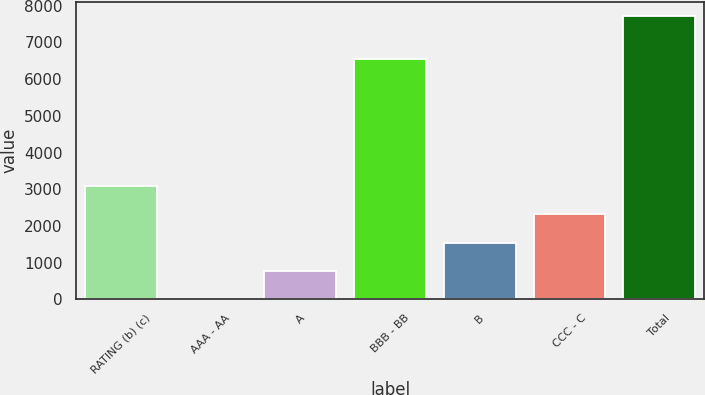Convert chart. <chart><loc_0><loc_0><loc_500><loc_500><bar_chart><fcel>RATING (b) (c)<fcel>AAA - AA<fcel>A<fcel>BBB - BB<fcel>B<fcel>CCC - C<fcel>Total<nl><fcel>3087.4<fcel>1<fcel>772.6<fcel>6549<fcel>1544.2<fcel>2315.8<fcel>7717<nl></chart> 